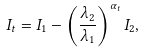Convert formula to latex. <formula><loc_0><loc_0><loc_500><loc_500>I _ { t } = I _ { 1 } - \left ( \frac { \lambda _ { 2 } } { \lambda _ { 1 } } \right ) ^ { \alpha _ { t } } I _ { 2 } ,</formula> 